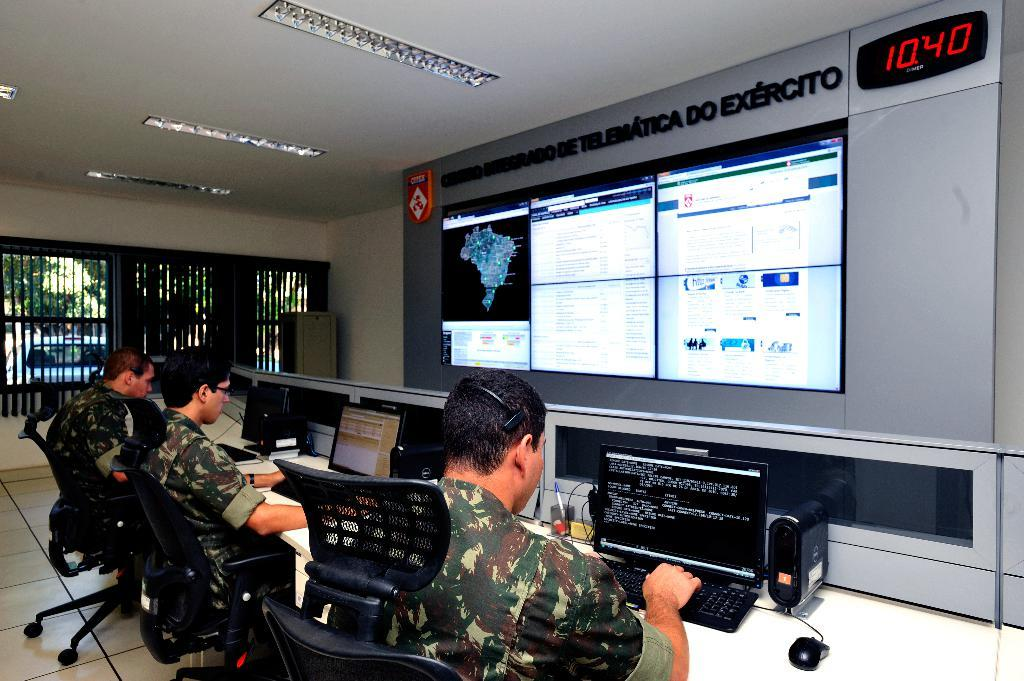<image>
Provide a brief description of the given image. a digital clock that reads 10:40 as the time 